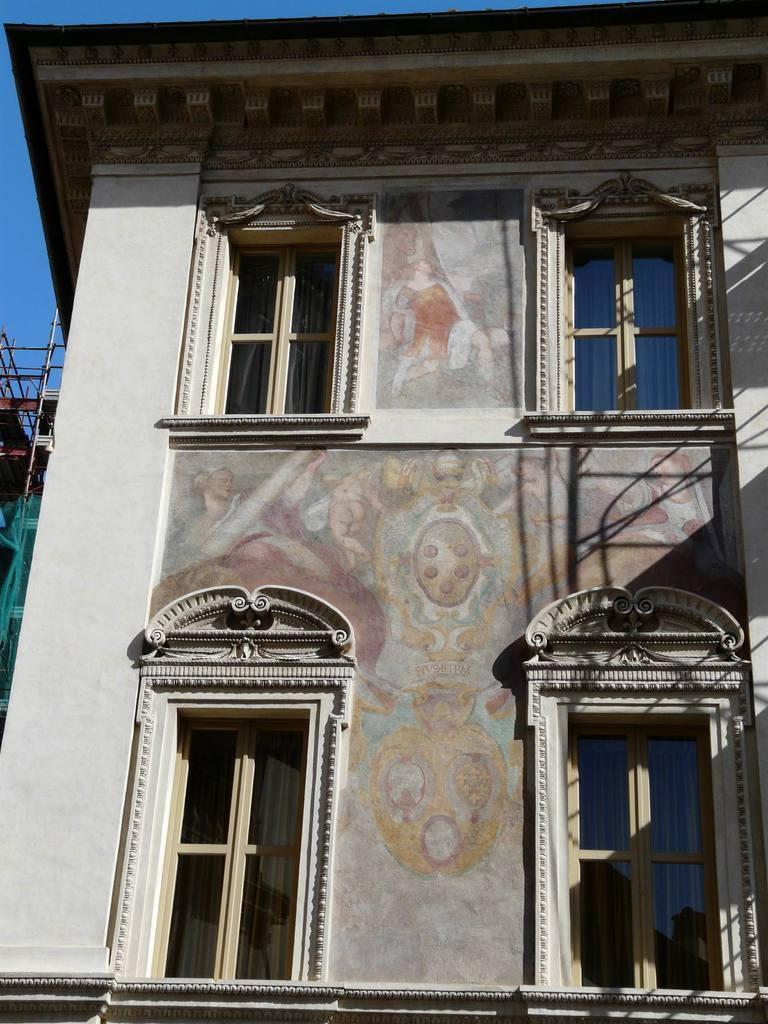Describe this image in one or two sentences. In this image in the center there is one building and on the building there is some art, and there are four windows. 